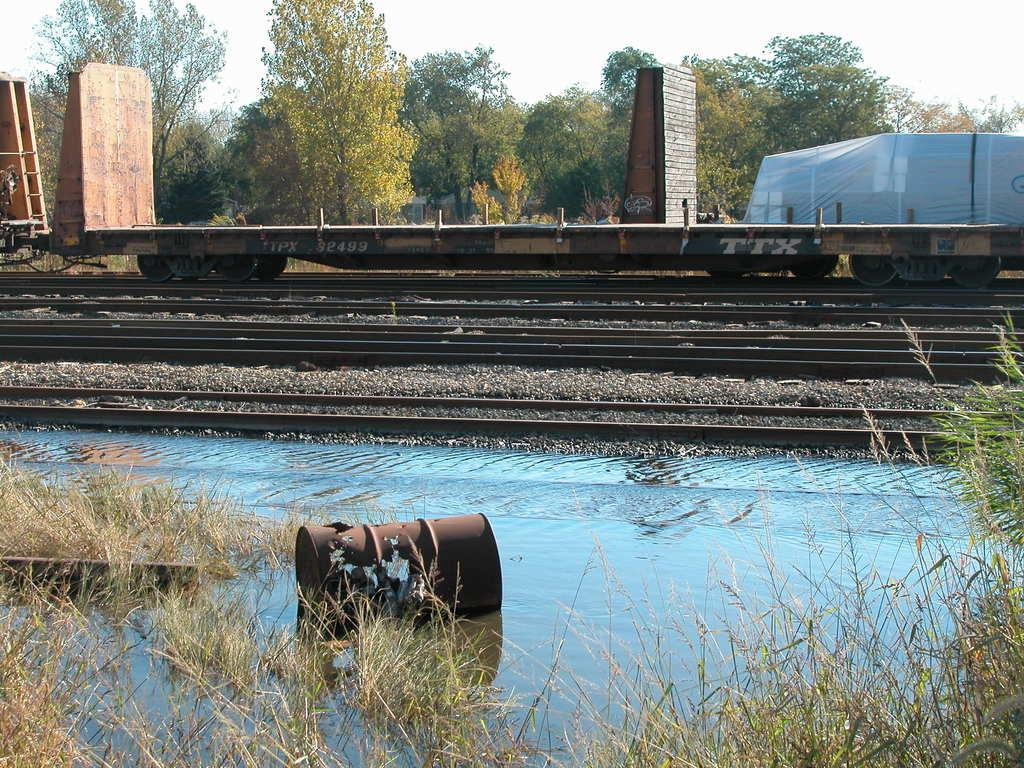What can be seen running along the ground in the image? There are railway tracks in the image. What is on the railway tracks in the image? There is a train on the railway tracks. What can be seen in the distance behind the train in the image? There are trees visible in the background of the image. What type of flower is growing on the train in the image? There are no flowers visible on the train in the image. 